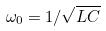Convert formula to latex. <formula><loc_0><loc_0><loc_500><loc_500>\omega _ { 0 } = 1 / \sqrt { L C }</formula> 